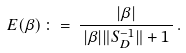Convert formula to latex. <formula><loc_0><loc_0><loc_500><loc_500>E ( \beta ) \, \colon = \, \frac { | \beta | } { \, | \beta | \| S _ { D } ^ { - 1 } \| + 1 \, } \, .</formula> 